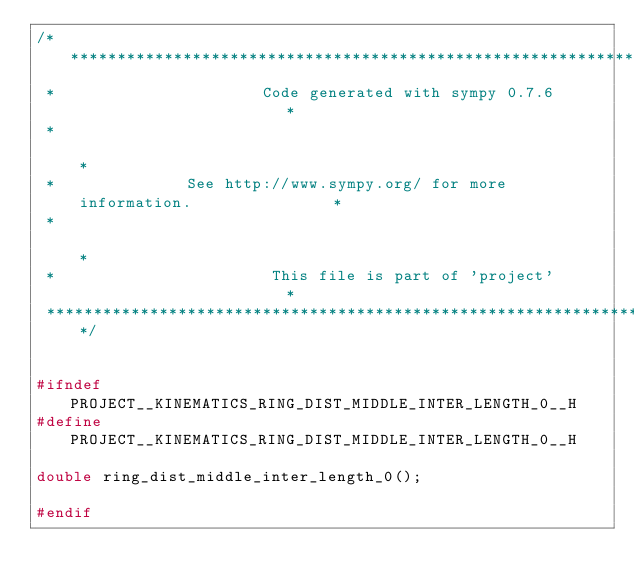<code> <loc_0><loc_0><loc_500><loc_500><_C_>/******************************************************************************
 *                      Code generated with sympy 0.7.6                       *
 *                                                                            *
 *              See http://www.sympy.org/ for more information.               *
 *                                                                            *
 *                       This file is part of 'project'                       *
 ******************************************************************************/


#ifndef PROJECT__KINEMATICS_RING_DIST_MIDDLE_INTER_LENGTH_0__H
#define PROJECT__KINEMATICS_RING_DIST_MIDDLE_INTER_LENGTH_0__H

double ring_dist_middle_inter_length_0();

#endif

</code> 